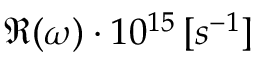Convert formula to latex. <formula><loc_0><loc_0><loc_500><loc_500>\Re ( \omega ) \cdot 1 0 ^ { 1 5 } \, [ s ^ { - 1 } ]</formula> 